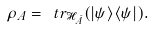Convert formula to latex. <formula><loc_0><loc_0><loc_500><loc_500>\rho _ { A } = \ t r _ { \mathcal { H } _ { \bar { A } } } ( | \psi \rangle \langle \psi | ) .</formula> 